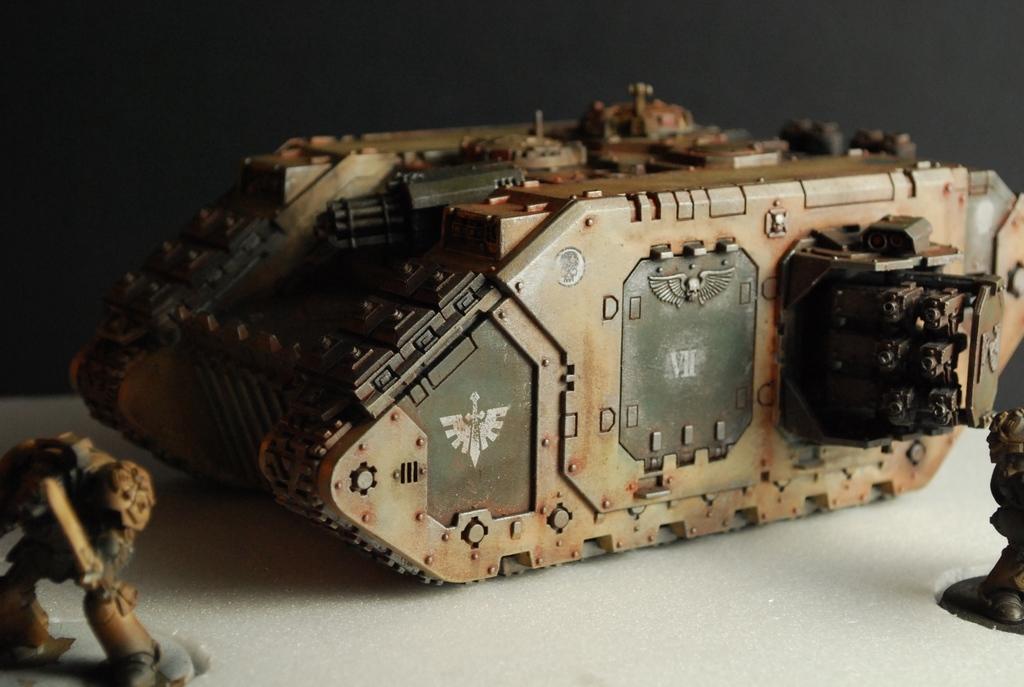How would you summarize this image in a sentence or two? In this image there are toys. 